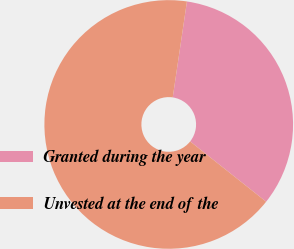<chart> <loc_0><loc_0><loc_500><loc_500><pie_chart><fcel>Granted during the year<fcel>Unvested at the end of the<nl><fcel>33.33%<fcel>66.67%<nl></chart> 